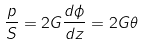Convert formula to latex. <formula><loc_0><loc_0><loc_500><loc_500>\frac { p } { S } = 2 G \frac { d \phi } { d z } = 2 G \theta</formula> 